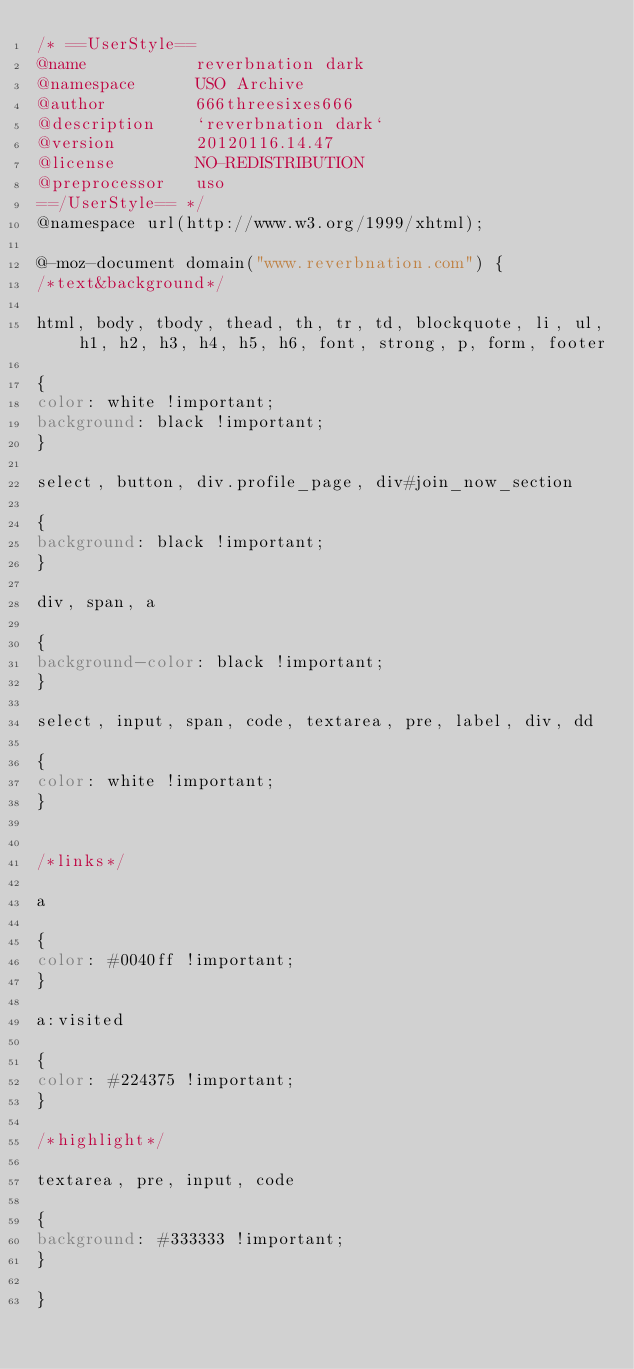<code> <loc_0><loc_0><loc_500><loc_500><_CSS_>/* ==UserStyle==
@name           reverbnation dark
@namespace      USO Archive
@author         666threesixes666
@description    `reverbnation dark`
@version        20120116.14.47
@license        NO-REDISTRIBUTION
@preprocessor   uso
==/UserStyle== */
@namespace url(http://www.w3.org/1999/xhtml);

@-moz-document domain("www.reverbnation.com") {
/*text&background*/

html, body, tbody, thead, th, tr, td, blockquote, li, ul, h1, h2, h3, h4, h5, h6, font, strong, p, form, footer

{
color: white !important;
background: black !important;
}

select, button, div.profile_page, div#join_now_section

{
background: black !important;
}

div, span, a

{
background-color: black !important;
}

select, input, span, code, textarea, pre, label, div, dd

{
color: white !important;
}


/*links*/

a

{
color: #0040ff !important;
}

a:visited

{
color: #224375 !important;
}

/*highlight*/

textarea, pre, input, code

{
background: #333333 !important;
}

}</code> 